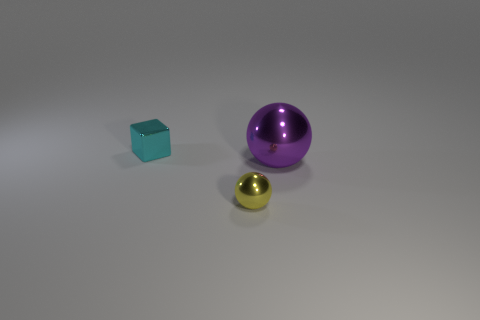Are there any small red metallic things that have the same shape as the large object?
Provide a short and direct response. No. There is a sphere that is behind the tiny yellow metallic sphere; is its size the same as the ball that is in front of the big ball?
Keep it short and to the point. No. Is the number of purple shiny objects that are behind the big object less than the number of tiny objects that are on the left side of the tiny cyan metal block?
Offer a very short reply. No. There is a object behind the large purple sphere; what is its color?
Your answer should be compact. Cyan. Do the large sphere and the block have the same color?
Provide a succinct answer. No. What number of objects are to the right of the tiny metal thing behind the small thing right of the cyan metallic thing?
Provide a short and direct response. 2. The yellow metallic sphere has what size?
Ensure brevity in your answer.  Small. What material is the yellow sphere that is the same size as the cyan metallic block?
Give a very brief answer. Metal. There is a small cyan shiny object; what number of purple metal things are in front of it?
Your response must be concise. 1. Do the small block behind the tiny ball and the small thing that is in front of the tiny cyan object have the same material?
Make the answer very short. Yes. 